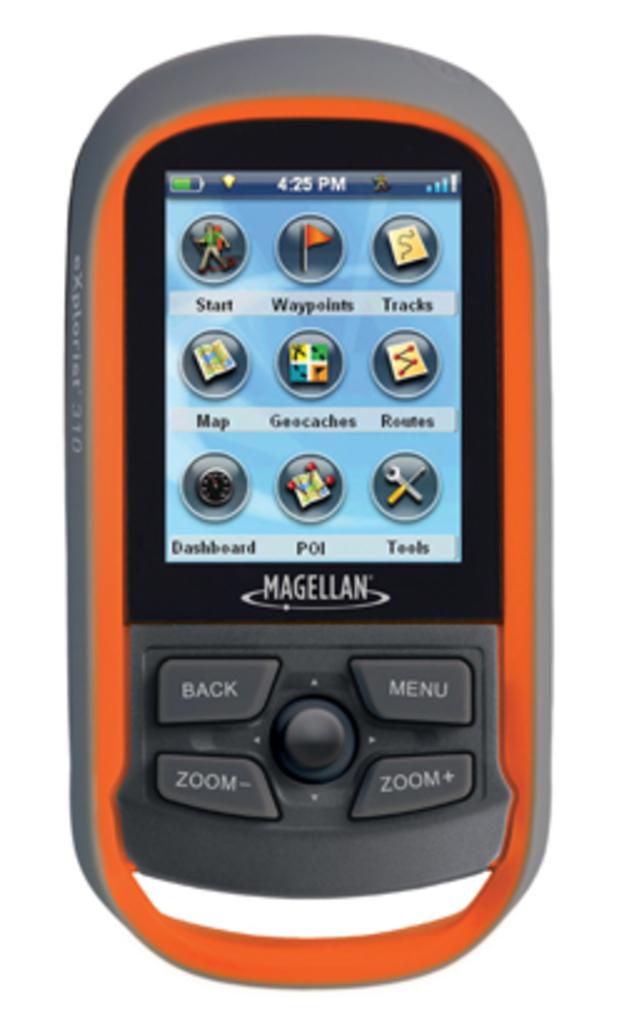<image>
Present a compact description of the photo's key features. a Magellan branded phone showing colorul icons on the screen 